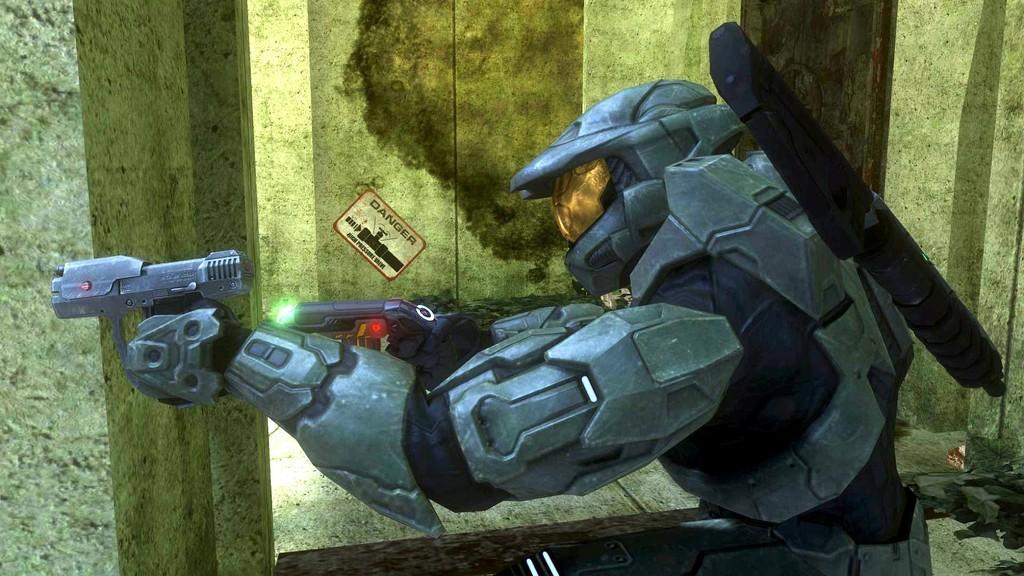Could you give a brief overview of what you see in this image? In this image I can see an animated image of the person wearing an armor. I can see the person is holding the guns. In the background I can see the sticker attached to the wall. 